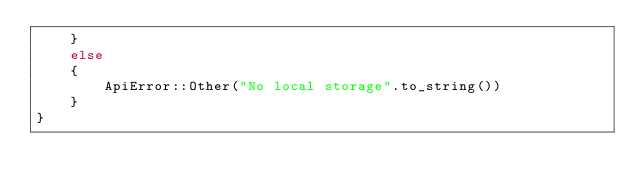<code> <loc_0><loc_0><loc_500><loc_500><_Rust_>	}
	else
	{
		ApiError::Other("No local storage".to_string())
	}
}
</code> 